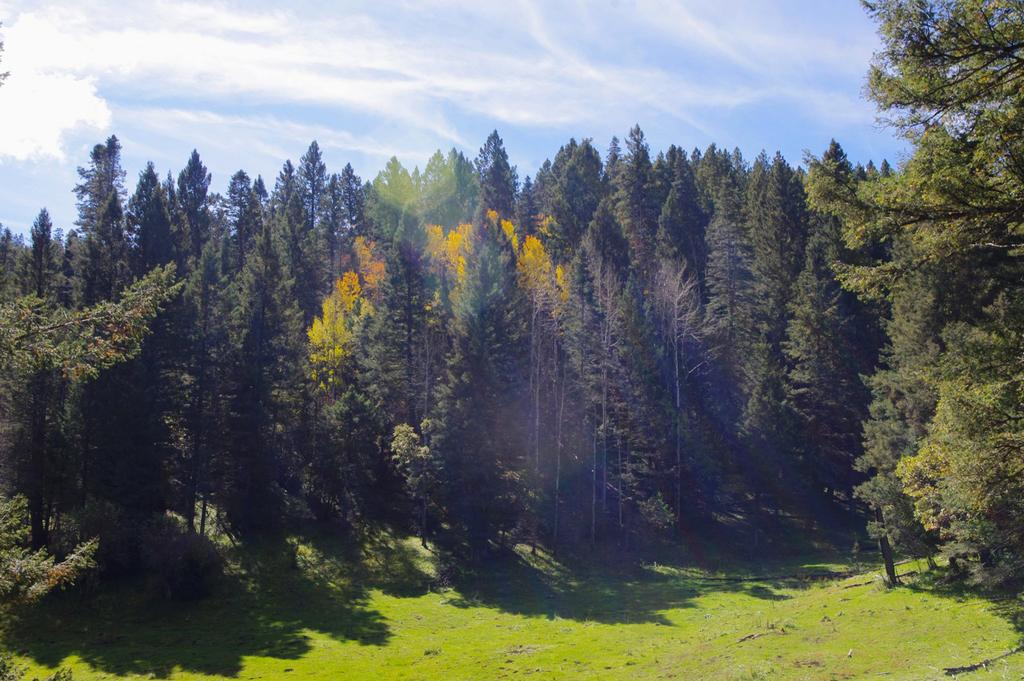What type of vegetation can be seen in the image? There is grass in the image. What other natural elements are present in the image? There are trees in the image. What can be seen in the sky in the image? There are clouds visible in the image. What discovery did the grandmother make while looking at the image? There is no mention of a grandmother or any discovery in the image, so it is not possible to answer that question. 